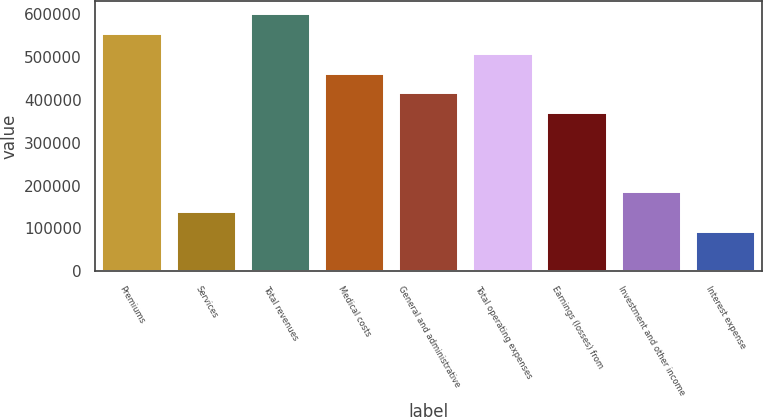Convert chart. <chart><loc_0><loc_0><loc_500><loc_500><bar_chart><fcel>Premiums<fcel>Services<fcel>Total revenues<fcel>Medical costs<fcel>General and administrative<fcel>Total operating expenses<fcel>Earnings (losses) from<fcel>Investment and other income<fcel>Interest expense<nl><fcel>553784<fcel>138447<fcel>599933<fcel>461487<fcel>415338<fcel>507636<fcel>369190<fcel>184596<fcel>92298.6<nl></chart> 